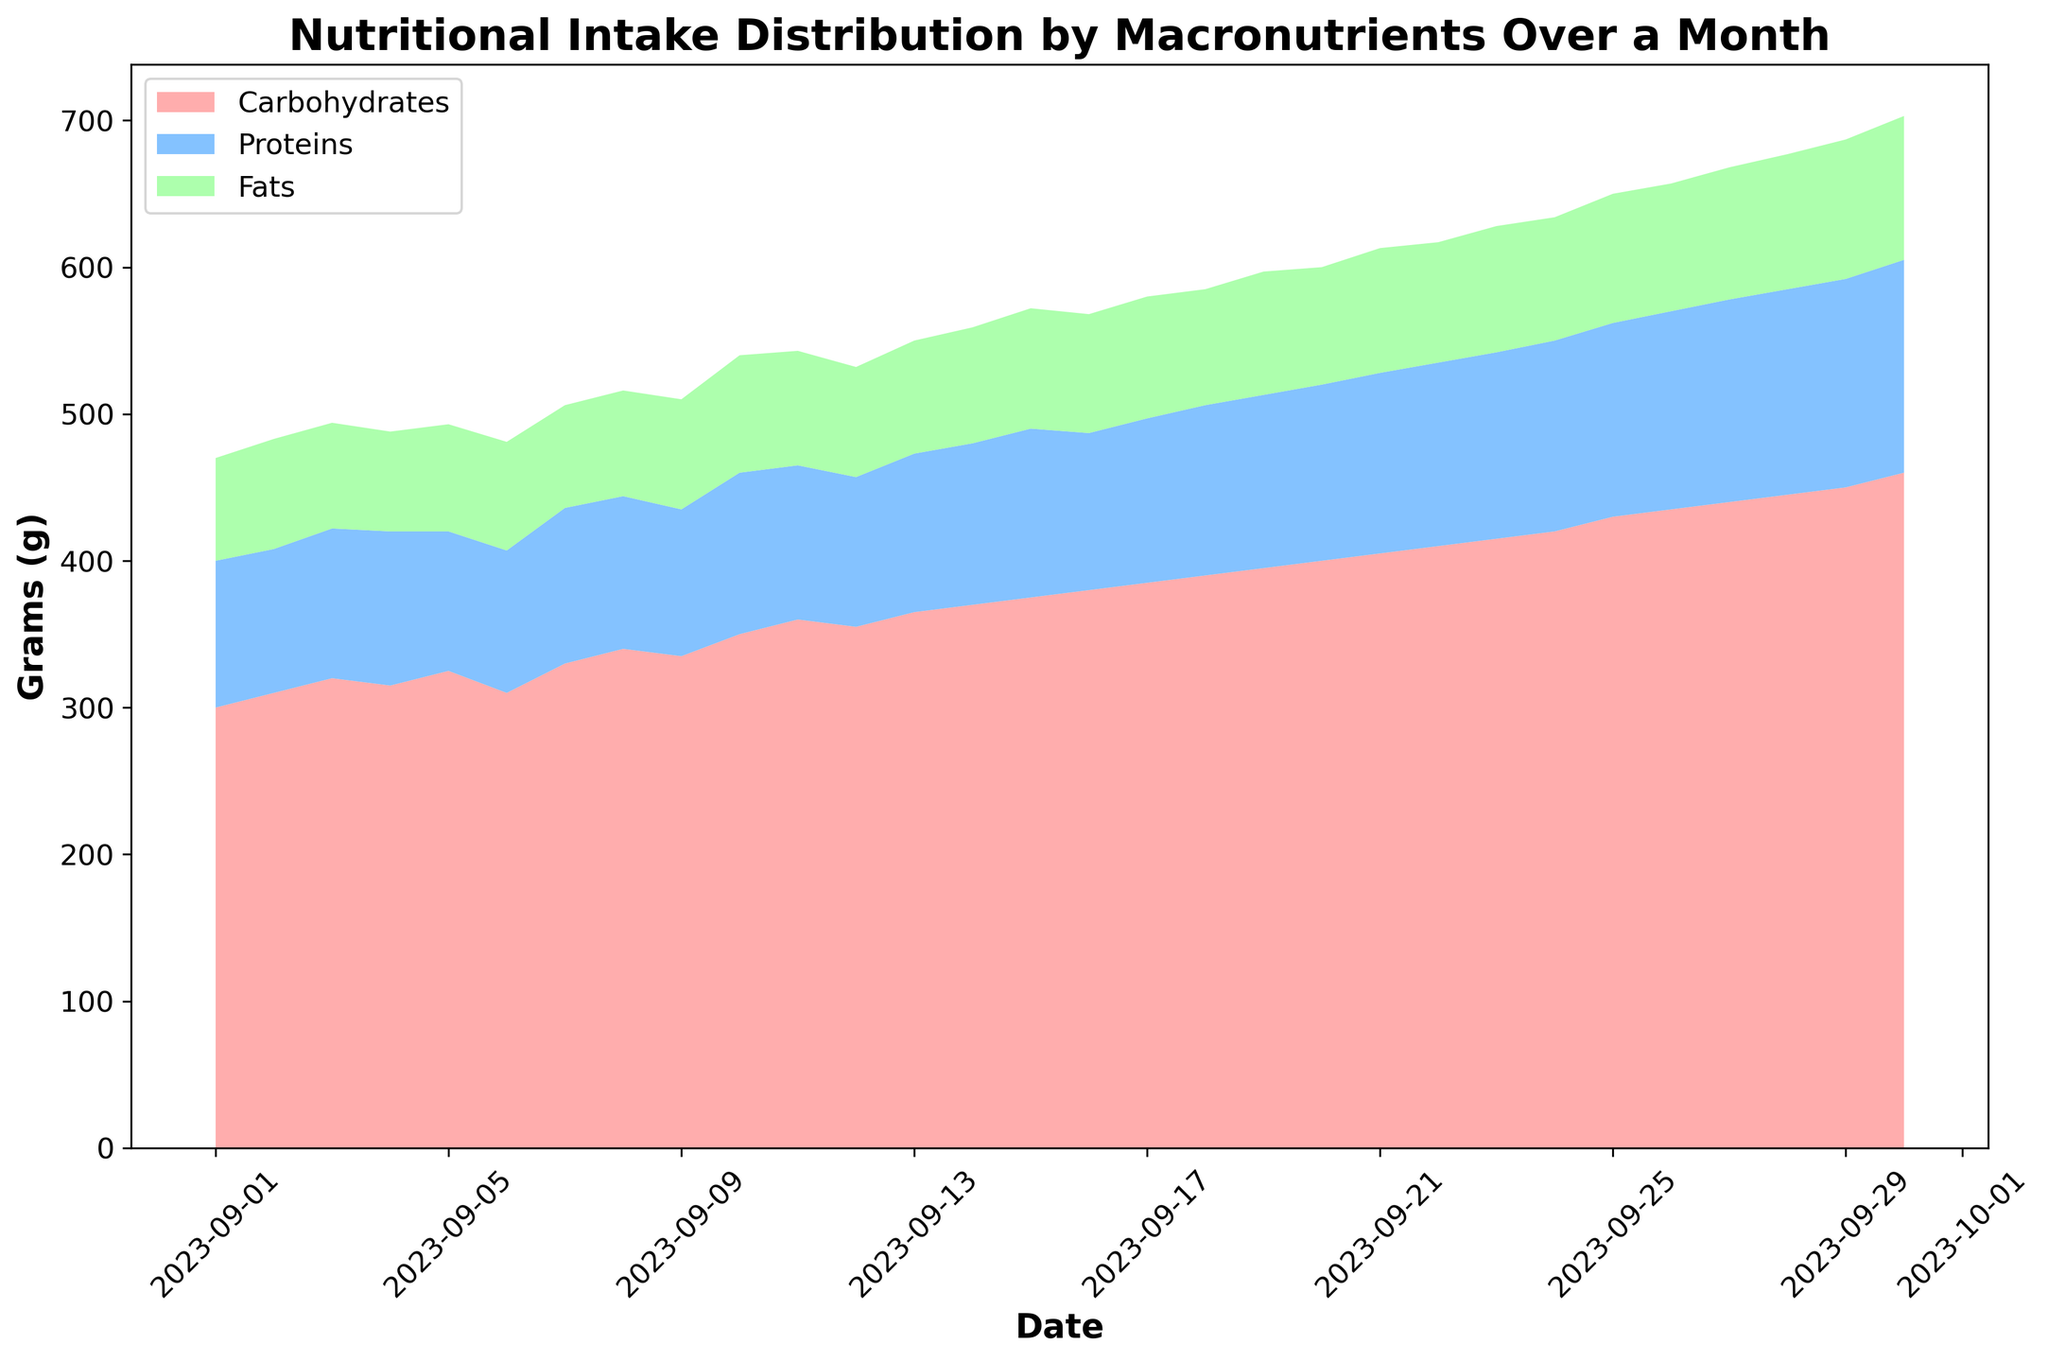what trend can be seen in the carbohydrate intake throughout the month? The area chart shows that the carbohydrate intake consistently increased over the duration of the month, starting from around 300 grams on September 1 and reaching approximately 460 grams on September 30. This can be observed as the increasing height of the red area towards the end of the month.
Answer: An increasing trend which macronutrient was consumed the least consistently? The area chart indicates that fat intake was the least consistent. The area representing fats (green) shows considerable fluctuations compared to carbohydrates and proteins, which have more steady increases.
Answer: Fats on which date was the intake of protein highest? By following the blue area to its peak, it can be observed that the largest intake of proteins occurred on September 30, reaching approximately 145 grams.
Answer: September 30 how did fat intake change from September 15 to September 20? On September 15, the fat intake is at approximately 82 grams. By September 20, it slightly decreased to around 80 grams, showing a minor dip over this period.
Answer: Decreased slightly compare the carbohydrate and protein intake on September 10. which one was higher and by how much? On September 10, carbohydrate intake was 350 grams and protein intake was 110 grams. Subtracting the protein value from the carbohydrate value gives 350 - 110 = 240 grams, indicating that carbohydrate intake was higher by 240 grams.
Answer: Carbohydrates were higher by 240 grams calculate the total intake of macronutrients (carbohydrates, proteins, and fats) on September 25. Adding up the values for carbohydrates, proteins, and fats on September 25: 430 grams (carbohydrates) + 132 grams (proteins) + 88 grams (fats) = 650 grams.
Answer: 650 grams what is the general relationship between protein intake and time? Observing the blue area in the chart from left to right, protein intake shows a general upward trend over the month, indicating that it increased over time.
Answer: Increasing trend how does the total macronutrient intake on September 15 compare to September 30? On September 15, the total macronutrient intake (carbs + proteins + fats) is 375 + 115 + 82 = 572 grams. On September 30, it's 460 + 145 + 98 = 703 grams. Comparing these, September 30 has a higher intake compared to September 15.
Answer: September 30 is higher which date shows the highest combined intake of all macronutrients? By observing the total height of all combined areas (red for carbohydrates, blue for proteins, and green for fats), September 30 shows the highest combined intake of all macronutrients.
Answer: September 30 which macronutrient shows the greatest variation in intake values over the month? Analyzing the areas and their fluctuations, protein intake (blue) shows marked consistent increases, while carbohydrates (red) also steadily increase. Fats (green), however, show the greatest fluctuations both up and down, indicating the greatest variation in intake values.
Answer: Fats 